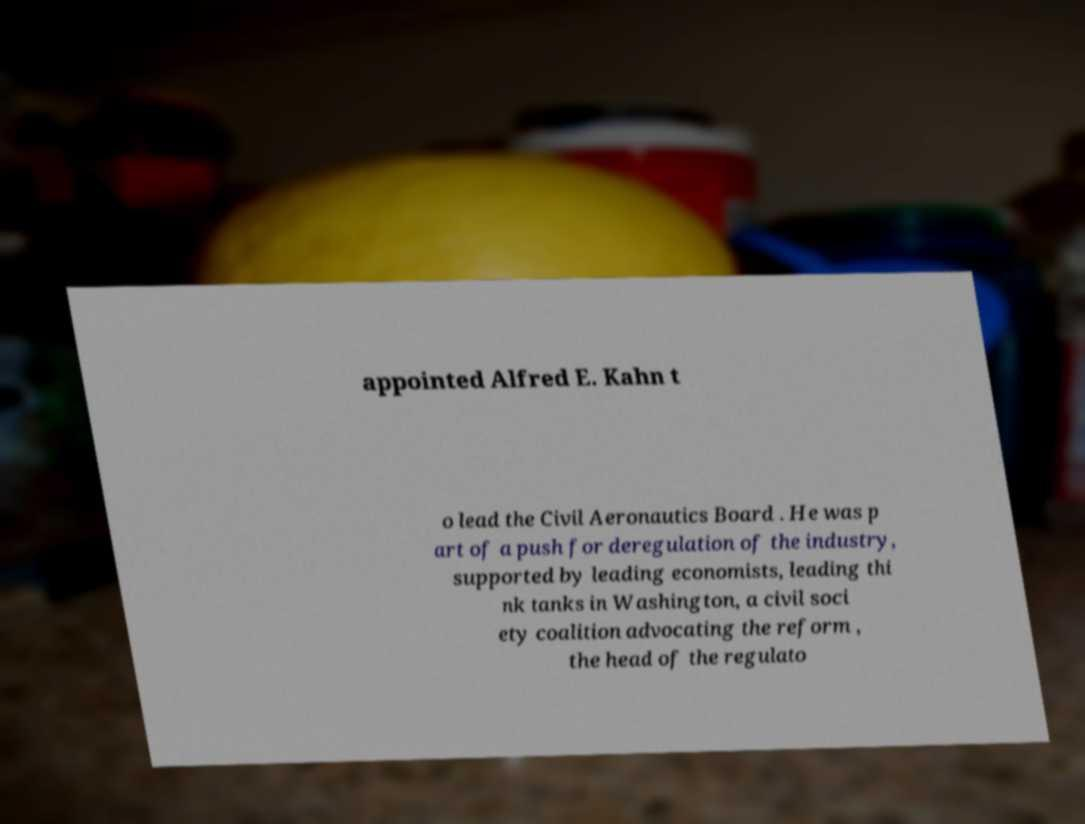What messages or text are displayed in this image? I need them in a readable, typed format. appointed Alfred E. Kahn t o lead the Civil Aeronautics Board . He was p art of a push for deregulation of the industry, supported by leading economists, leading thi nk tanks in Washington, a civil soci ety coalition advocating the reform , the head of the regulato 